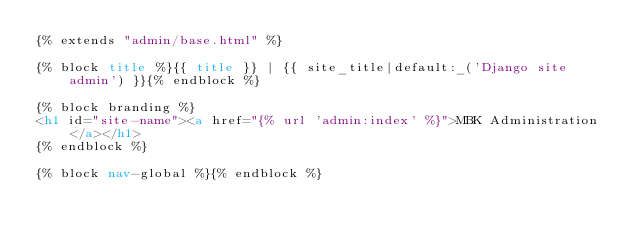<code> <loc_0><loc_0><loc_500><loc_500><_HTML_>{% extends "admin/base.html" %}

{% block title %}{{ title }} | {{ site_title|default:_('Django site admin') }}{% endblock %}

{% block branding %}
<h1 id="site-name"><a href="{% url 'admin:index' %}">MBK Administration</a></h1>
{% endblock %}

{% block nav-global %}{% endblock %}
</code> 